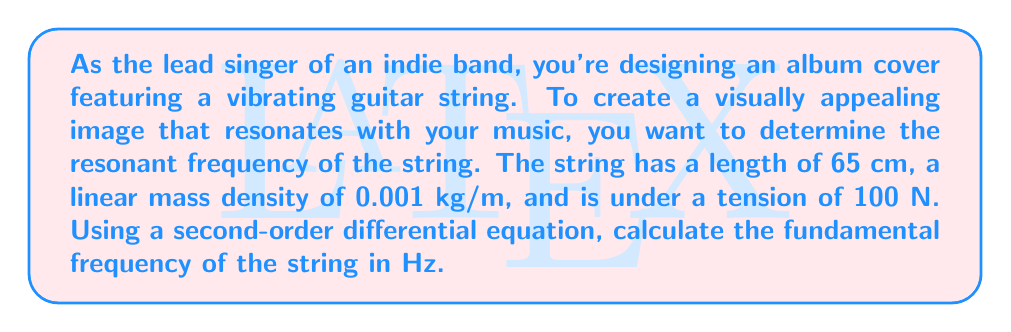Solve this math problem. To solve this problem, we'll use the wave equation for a vibrating string, which is a second-order partial differential equation:

$$\frac{\partial^2 y}{\partial t^2} = v^2 \frac{\partial^2 y}{\partial x^2}$$

Where $y$ is the displacement of the string, $t$ is time, $x$ is position along the string, and $v$ is the wave speed.

1. First, we need to calculate the wave speed $v$:
   $$v = \sqrt{\frac{T}{\mu}}$$
   Where $T$ is tension and $\mu$ is linear mass density.
   
   $$v = \sqrt{\frac{100 \text{ N}}{0.001 \text{ kg/m}}} = 316.23 \text{ m/s}$$

2. The fundamental frequency $f$ of a vibrating string is given by:
   $$f = \frac{v}{2L}$$
   Where $L$ is the length of the string.

3. Substituting our values:
   $$f = \frac{316.23 \text{ m/s}}{2 \cdot 0.65 \text{ m}}$$

4. Calculate the result:
   $$f = 243.25 \text{ Hz}$$

This frequency represents the fundamental mode of vibration for the string, which will produce the lowest pitch and create the most visually striking standing wave pattern for the album cover.
Answer: The fundamental frequency of the guitar string is approximately 243.25 Hz. 